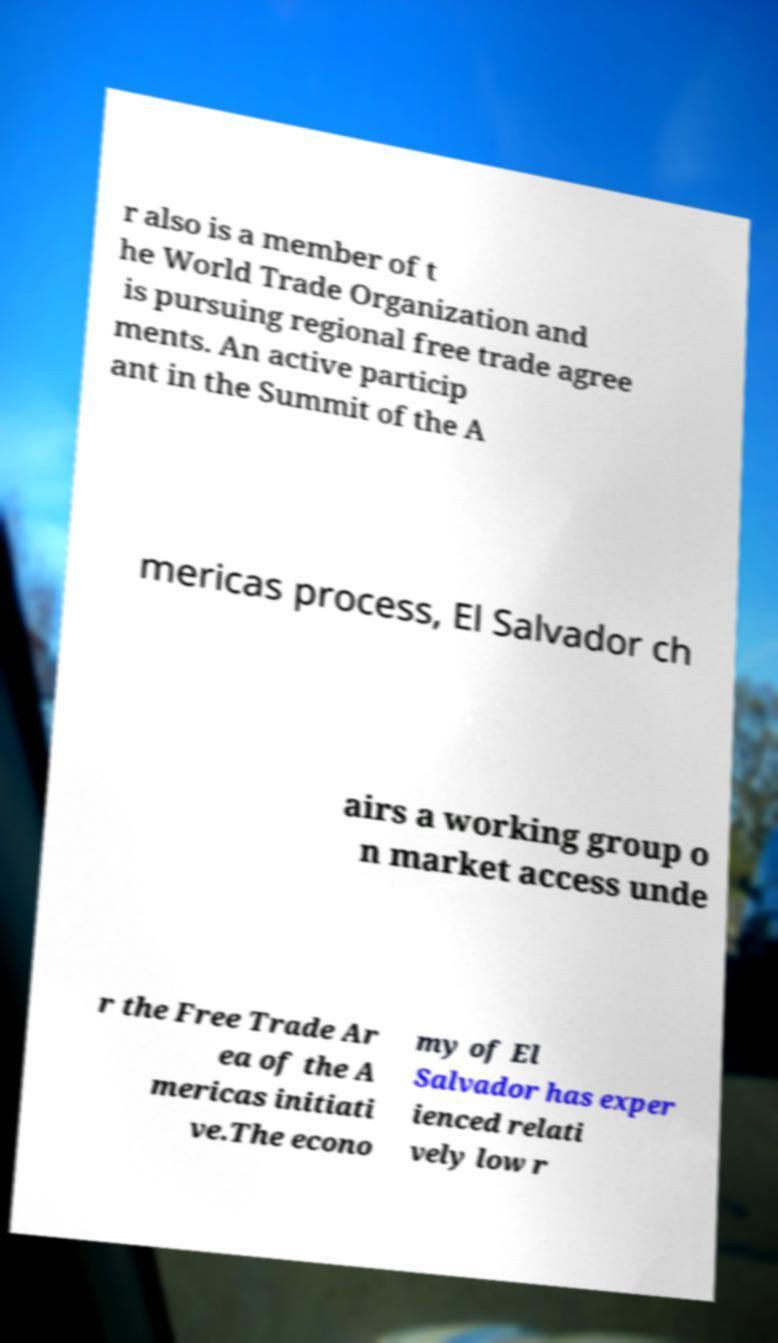Please identify and transcribe the text found in this image. r also is a member of t he World Trade Organization and is pursuing regional free trade agree ments. An active particip ant in the Summit of the A mericas process, El Salvador ch airs a working group o n market access unde r the Free Trade Ar ea of the A mericas initiati ve.The econo my of El Salvador has exper ienced relati vely low r 